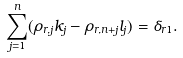<formula> <loc_0><loc_0><loc_500><loc_500>\sum _ { j = 1 } ^ { n } ( \rho _ { r , j } k _ { j } - \rho _ { r , n + j } l _ { j } ) = \delta _ { r 1 } .</formula> 